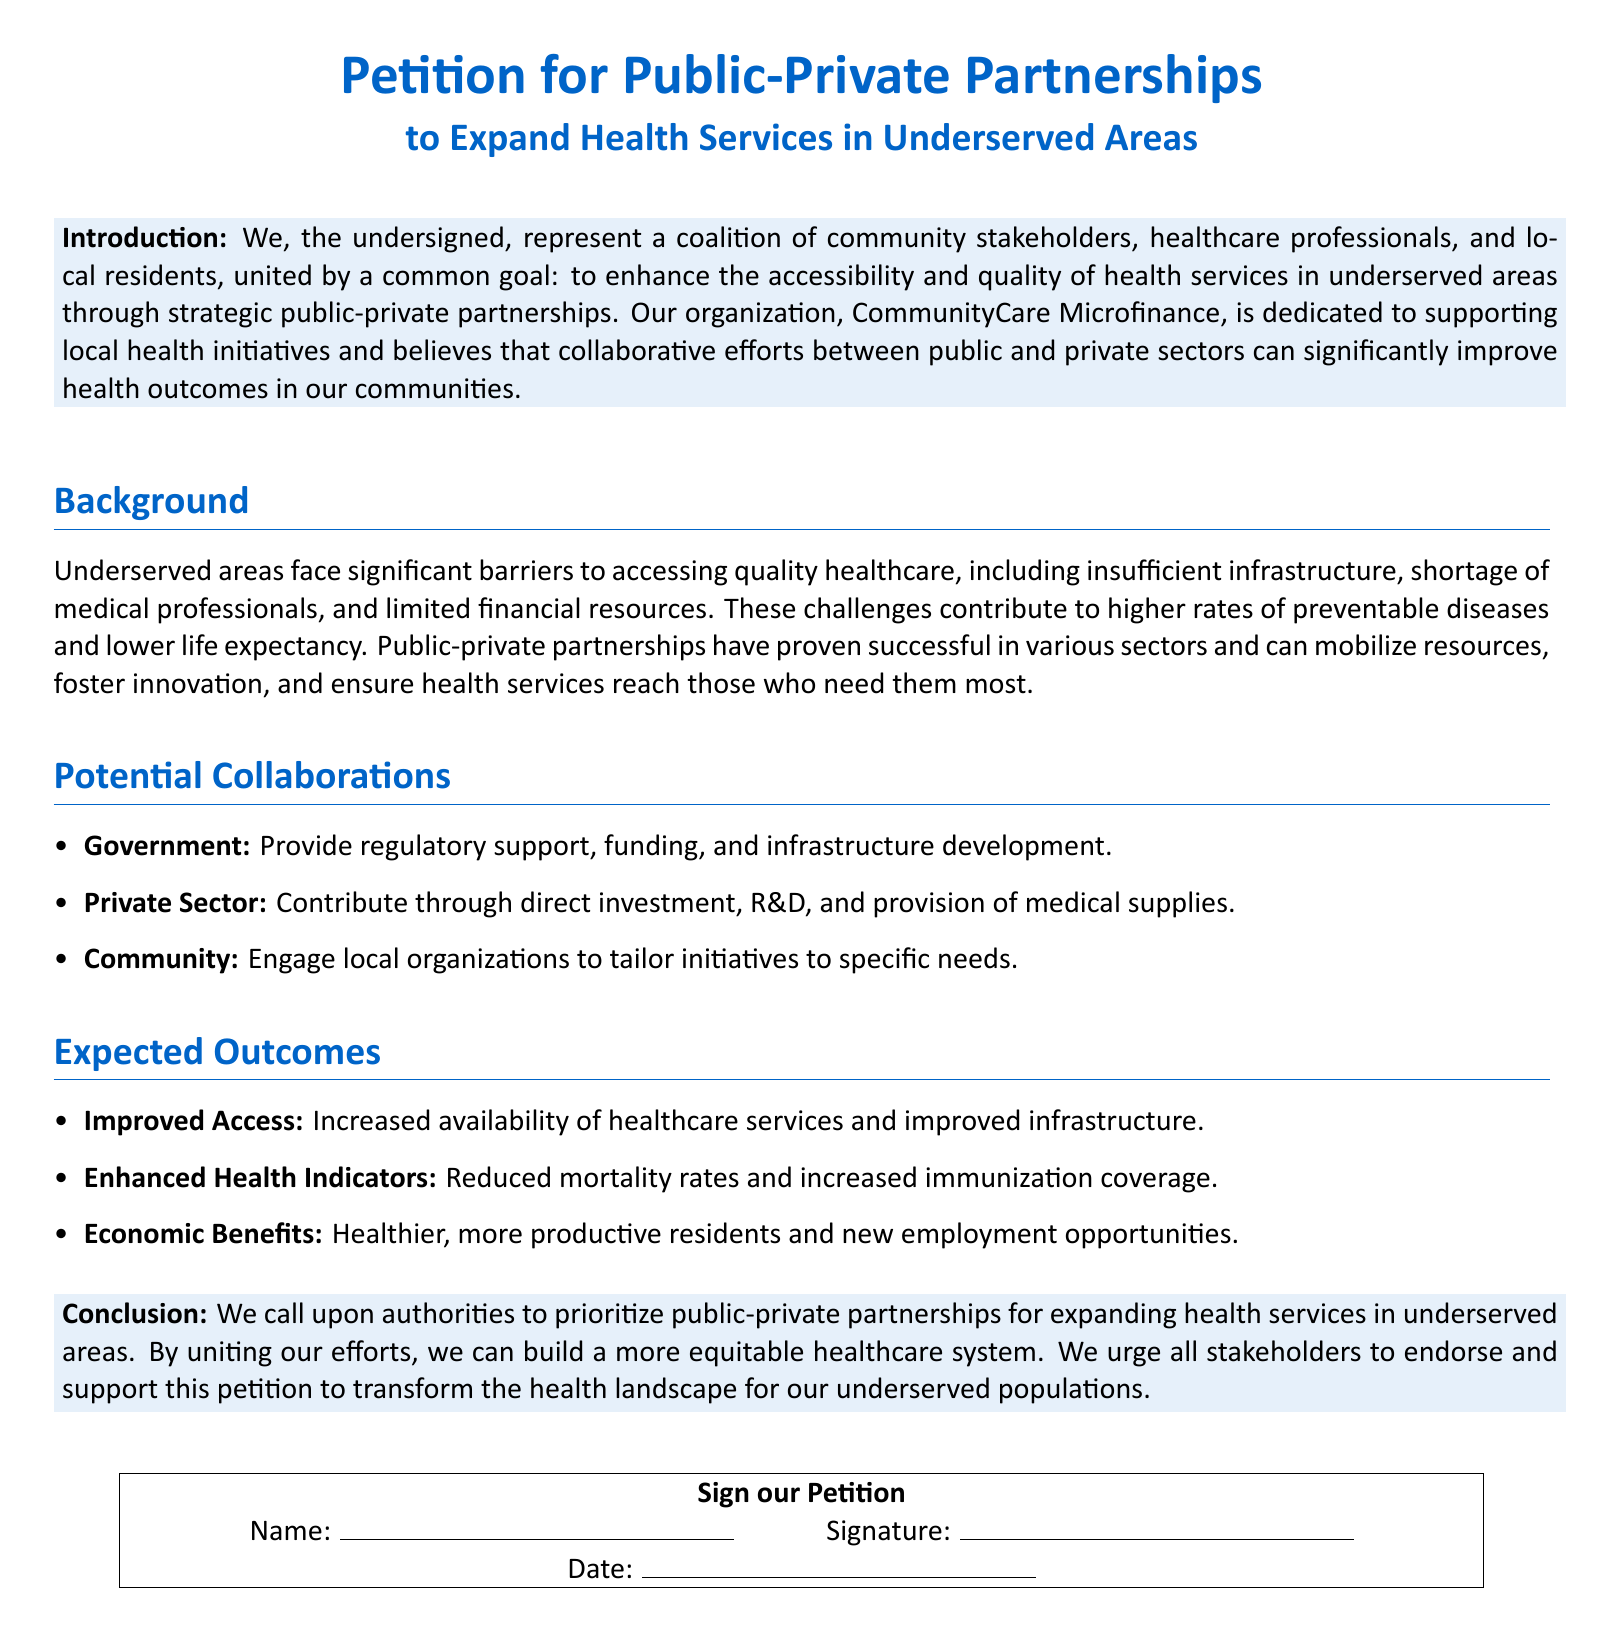What is the main goal of the petition? The petition aims to enhance accessibility and quality of health services in underserved areas through strategic public-private partnerships.
Answer: Enhance accessibility and quality of health services Who represents the coalition in this petition? The coalition is represented by community stakeholders, healthcare professionals, and local residents.
Answer: Community stakeholders, healthcare professionals, and local residents What type of support is the government expected to provide? The government is expected to provide regulatory support, funding, and infrastructure development.
Answer: Regulatory support, funding, and infrastructure development What is one expected outcome of the partnership? One expected outcome is reduced mortality rates and increased immunization coverage.
Answer: Reduced mortality rates and increased immunization coverage Which organization is dedicated to supporting local health initiatives? The organization dedicated to supporting local health initiatives is CommunityCare Microfinance.
Answer: CommunityCare Microfinance What does the conclusion of the petition urge all stakeholders to do? The conclusion urges all stakeholders to endorse and support the petition.
Answer: Endorse and support the petition 